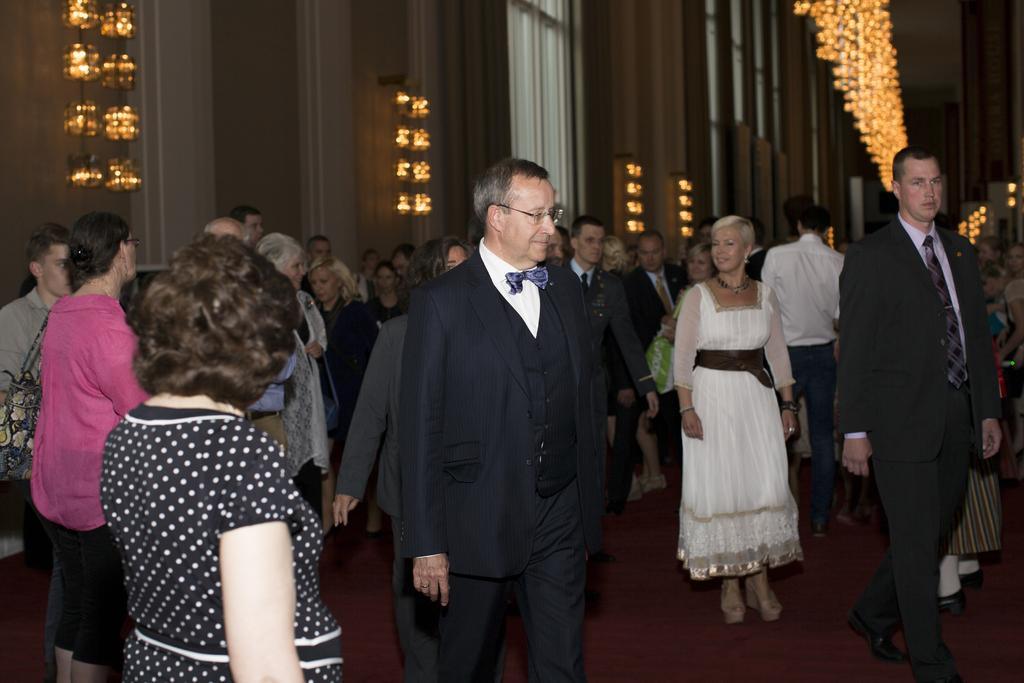Describe this image in one or two sentences. In this image there are group of persons, there is a person truncated towards the left of the image, there are persons truncated towards the bottom of the image, there is a person truncated towards the right of the image, there are lights truncated towards the top of the image, there is wall truncated towards the top of the image, there are windows truncated towards the top of the image. 